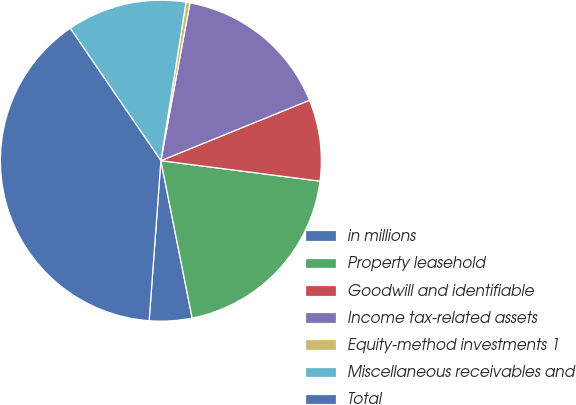Convert chart. <chart><loc_0><loc_0><loc_500><loc_500><pie_chart><fcel>in millions<fcel>Property leasehold<fcel>Goodwill and identifiable<fcel>Income tax-related assets<fcel>Equity-method investments 1<fcel>Miscellaneous receivables and<fcel>Total<nl><fcel>4.29%<fcel>19.84%<fcel>8.18%<fcel>15.95%<fcel>0.4%<fcel>12.06%<fcel>39.28%<nl></chart> 